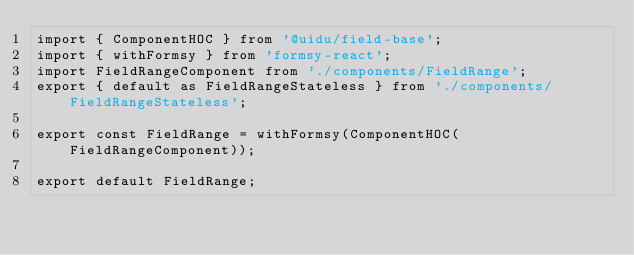<code> <loc_0><loc_0><loc_500><loc_500><_TypeScript_>import { ComponentHOC } from '@uidu/field-base';
import { withFormsy } from 'formsy-react';
import FieldRangeComponent from './components/FieldRange';
export { default as FieldRangeStateless } from './components/FieldRangeStateless';

export const FieldRange = withFormsy(ComponentHOC(FieldRangeComponent));

export default FieldRange;
</code> 